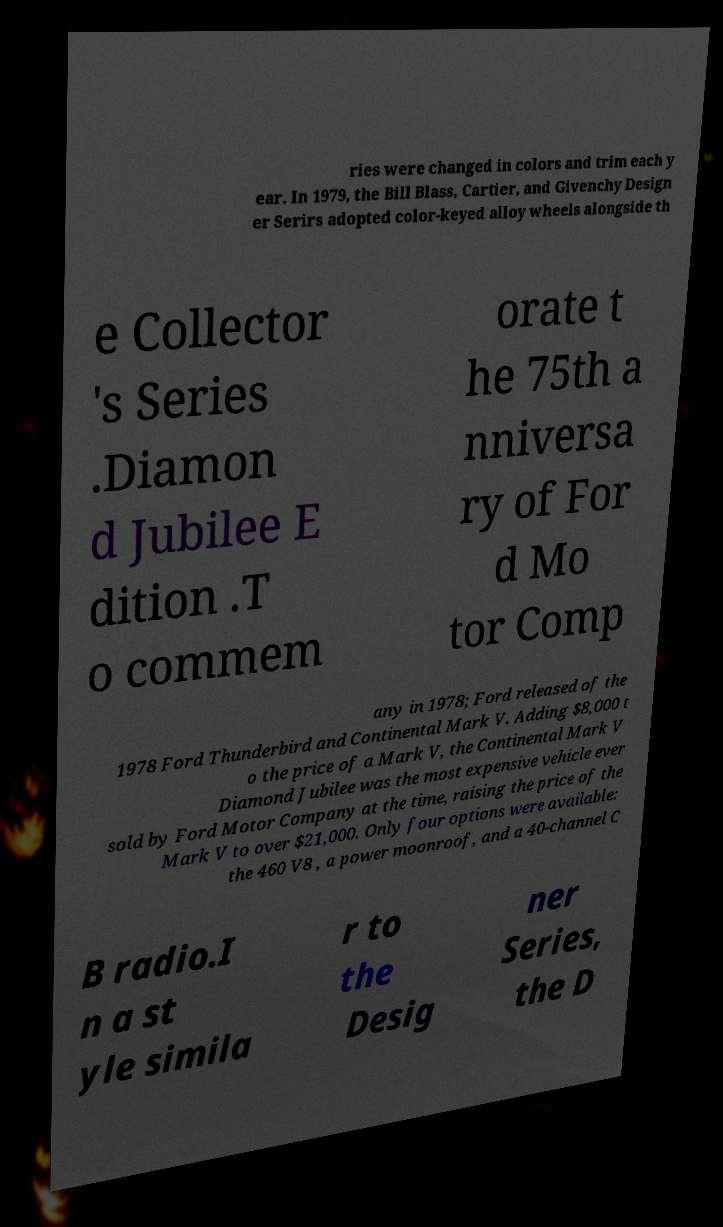There's text embedded in this image that I need extracted. Can you transcribe it verbatim? ries were changed in colors and trim each y ear. In 1979, the Bill Blass, Cartier, and Givenchy Design er Serirs adopted color-keyed alloy wheels alongside th e Collector 's Series .Diamon d Jubilee E dition .T o commem orate t he 75th a nniversa ry of For d Mo tor Comp any in 1978; Ford released of the 1978 Ford Thunderbird and Continental Mark V. Adding $8,000 t o the price of a Mark V, the Continental Mark V Diamond Jubilee was the most expensive vehicle ever sold by Ford Motor Company at the time, raising the price of the Mark V to over $21,000. Only four options were available: the 460 V8 , a power moonroof, and a 40-channel C B radio.I n a st yle simila r to the Desig ner Series, the D 